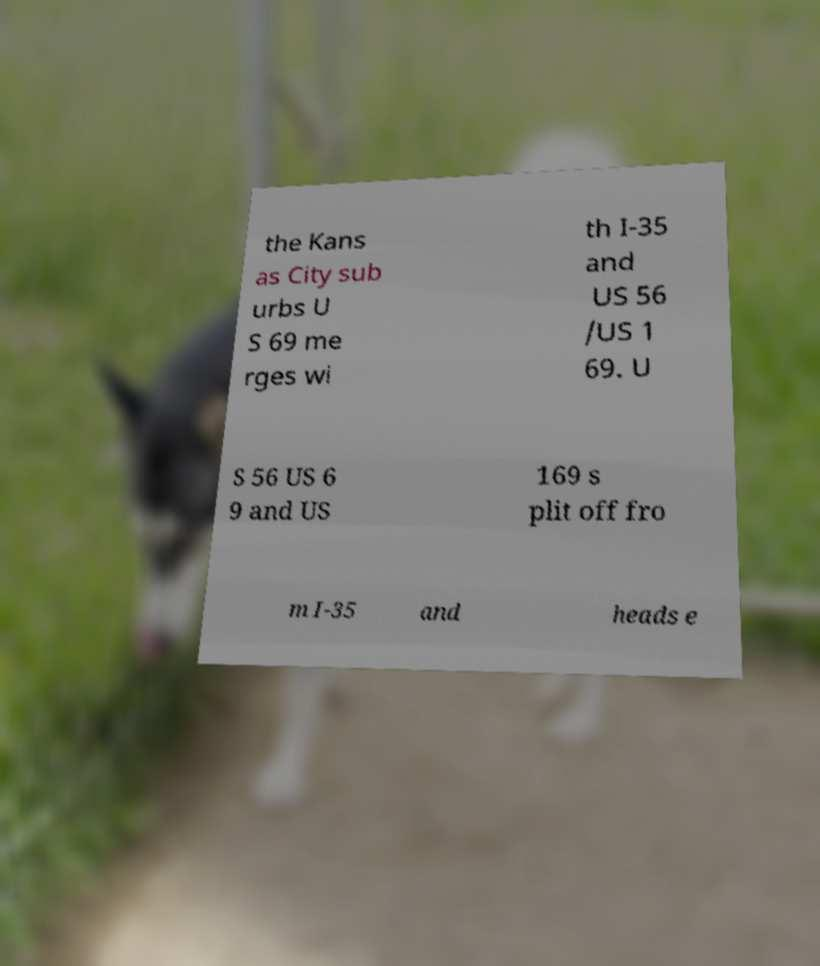For documentation purposes, I need the text within this image transcribed. Could you provide that? the Kans as City sub urbs U S 69 me rges wi th I-35 and US 56 /US 1 69. U S 56 US 6 9 and US 169 s plit off fro m I-35 and heads e 